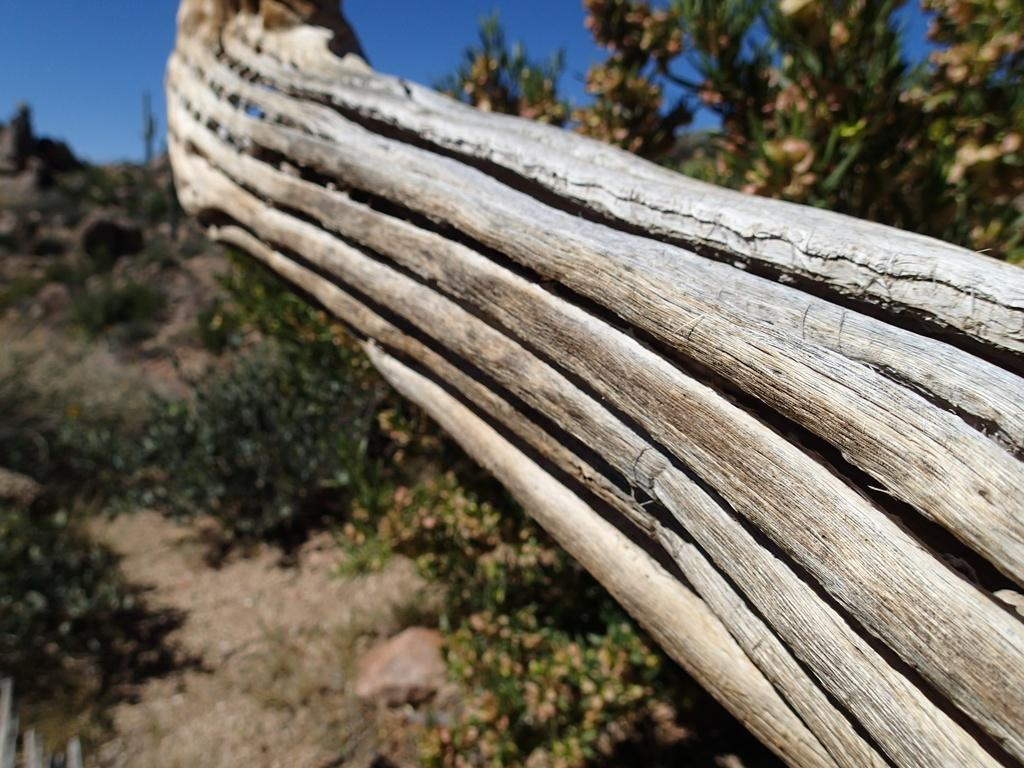What type of vegetation can be seen in the image? There are trees in the image. How would you describe the background of the image? The background of the image is blurry. Can you see a baby playing in front of the trees in the image? There is no baby present in the image. 